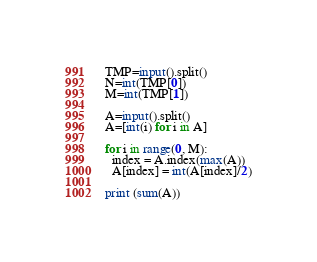Convert code to text. <code><loc_0><loc_0><loc_500><loc_500><_Python_>TMP=input().split()
N=int(TMP[0])
M=int(TMP[1])

A=input().split()
A=[int(i) for i in A]

for i in range(0, M):
  index = A.index(max(A))
  A[index] = int(A[index]/2)

print (sum(A))
</code> 